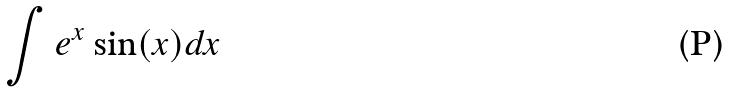<formula> <loc_0><loc_0><loc_500><loc_500>\int e ^ { x } \sin ( x ) d x</formula> 